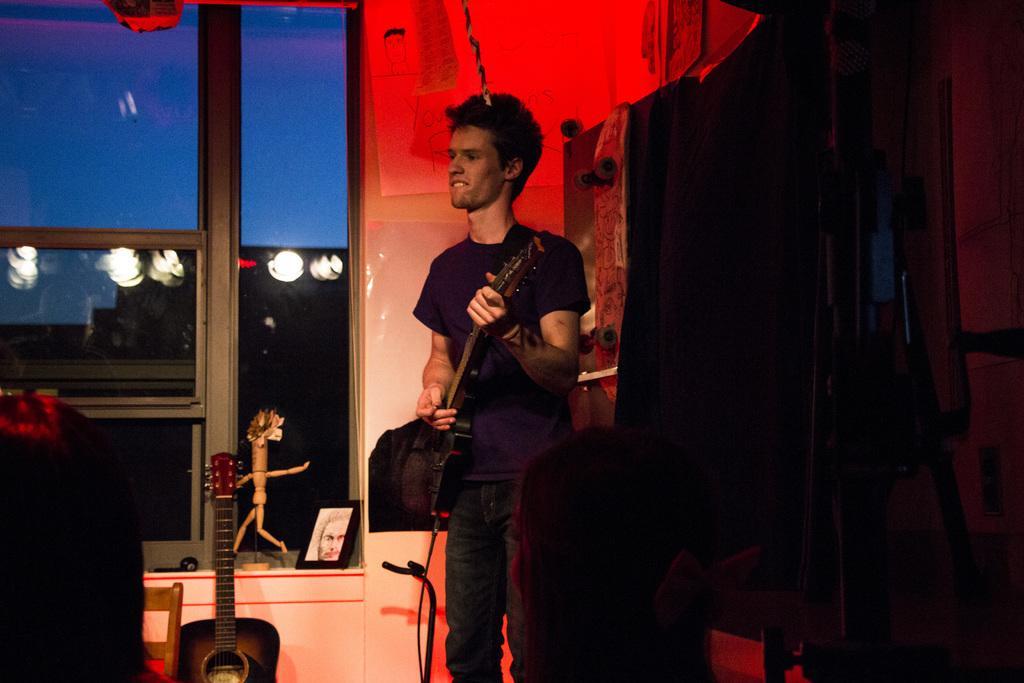How would you summarize this image in a sentence or two? In this image I can see the person with the musical instrument. To the side of the person I can see an another musical instrument. I can see another person in the front. In the background I can see the window and I can see the photo frame and an object on the window. 